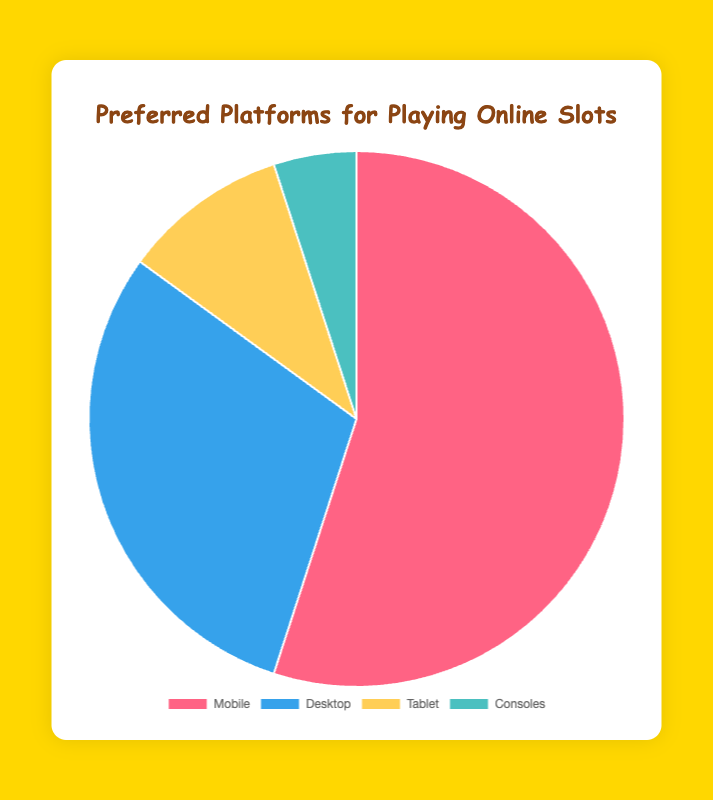What percentage of users prefer playing online slots on tablets? From the pie chart, the segment labeled "Tablet" represents the percentage of users who prefer tablets. The label shows 10%.
Answer: 10% Which platform is more popular for playing online slots, Mobile or Desktop? The pie chart has a segment labeled "Mobile" with 55% and another labeled "Desktop" with 30%. Comparing these, Mobile's 55% is greater than Desktop's 30%.
Answer: Mobile What is the total percentage of users who prefer playing online slots on Desktop and Consoles combined? The chart shows Desktop at 30% and Consoles at 5%. Adding these percentages together gives 30% + 5% = 35%.
Answer: 35% What is the percentage difference between users who prefer Mobile and Tablet for playing online slots? The percentage for Mobile is 55% and for Tablet is 10%. The difference between these percentages is 55% - 10% = 45%.
Answer: 45% Which platform has the smallest user preference for playing online slots and what color represents it? The portion of the pie chart labeled "Consoles" is the smallest, representing 5%. This segment is colored in a shade of teal.
Answer: Consoles, teal How much larger is the Mobile preference compared to the Desktop preference for playing online slots? The preference for Mobile is 55%, and for Desktop, it is 30%. Subtracting Desktop’s percentage from Mobile’s gives 55% - 30% = 25%.
Answer: 25% What is the sum of the percentages for platforms other than Mobile? The chart shows Desktop at 30%, Tablet at 10%, and Consoles at 5%. Summing these values gives 30% + 10% + 5% = 45%.
Answer: 45% Which two platforms combined have a user preference exactly equal to that of Mobile users for playing online slots? The chart shows Desktop at 30% and Tablet at 10%, which sum to 40%—this is less than Mobile's 55% but close. Alternatively, summing Desktop (30%) and Consoles (5%) does not equal Mobile's 55% either. Therefore, no two platforms combined exactly match 55%.
Answer: None Of the four platforms, which one is represented by the yellow segment on the pie chart, and what is its user preference percentage? The yellow segment on the pie chart represents Tablet. The user preference percentage for Tablet is 10%.
Answer: Tablet, 10% Which platform's user preference is double that of Console users? From the pie chart, Tablet has a 10% preference, and Consoles have a 5% preference. 10% is double the 5% preferenced Segment of Consoles.
Answer: Tablet 